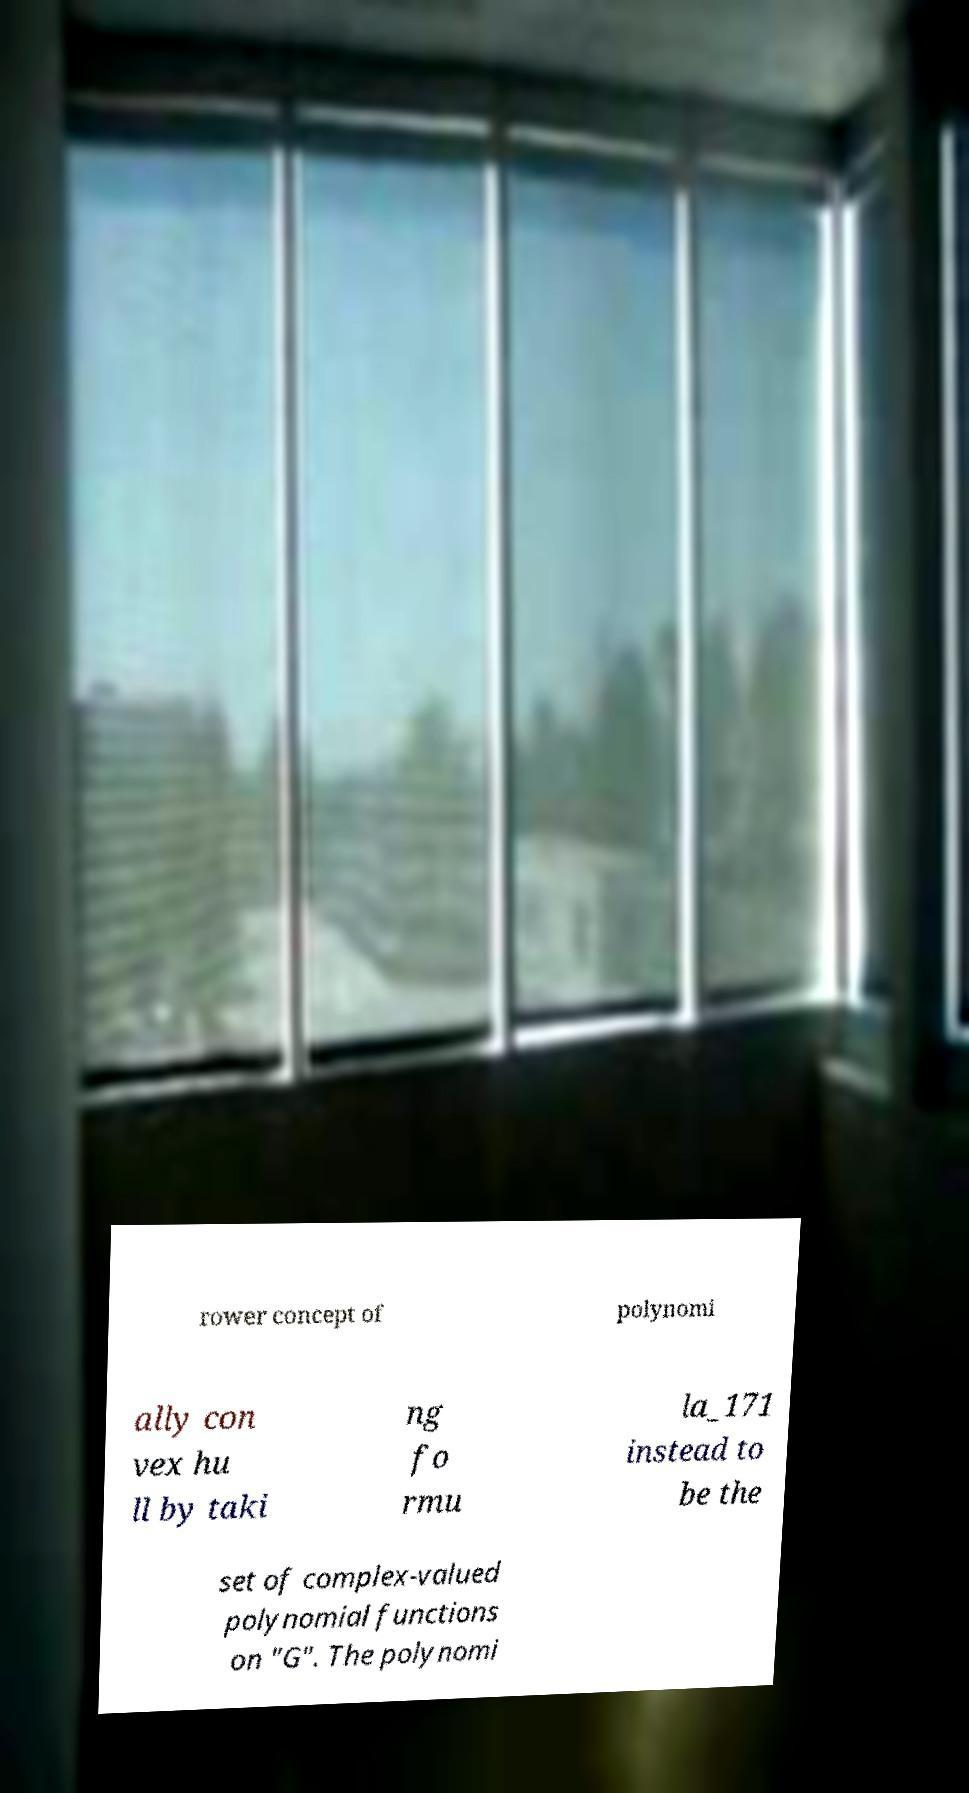Please read and relay the text visible in this image. What does it say? rower concept of polynomi ally con vex hu ll by taki ng fo rmu la_171 instead to be the set of complex-valued polynomial functions on "G". The polynomi 